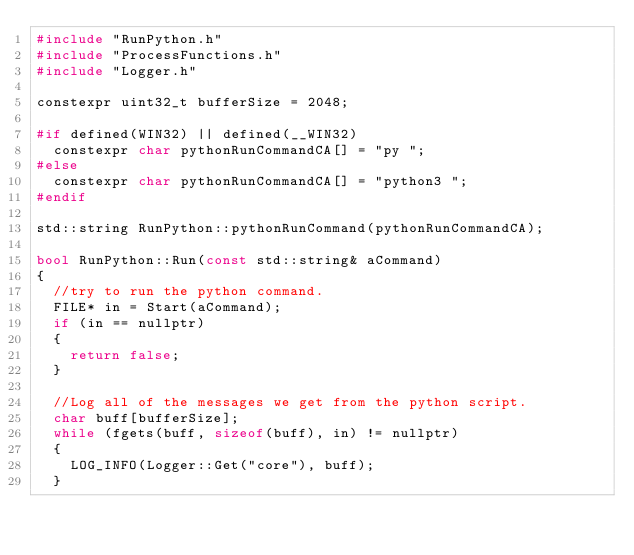<code> <loc_0><loc_0><loc_500><loc_500><_C++_>#include "RunPython.h"
#include "ProcessFunctions.h"
#include "Logger.h"

constexpr uint32_t bufferSize = 2048;

#if defined(WIN32) || defined(__WIN32)
	constexpr char pythonRunCommandCA[] = "py ";
#else
	constexpr char pythonRunCommandCA[] = "python3 ";
#endif

std::string RunPython::pythonRunCommand(pythonRunCommandCA);

bool RunPython::Run(const std::string& aCommand)
{
	//try to run the python command.
	FILE* in = Start(aCommand);
	if (in == nullptr)
	{
		return false;
	}

	//Log all of the messages we get from the python script.
	char buff[bufferSize];
	while (fgets(buff, sizeof(buff), in) != nullptr)
	{
		LOG_INFO(Logger::Get("core"), buff);
	}
</code> 